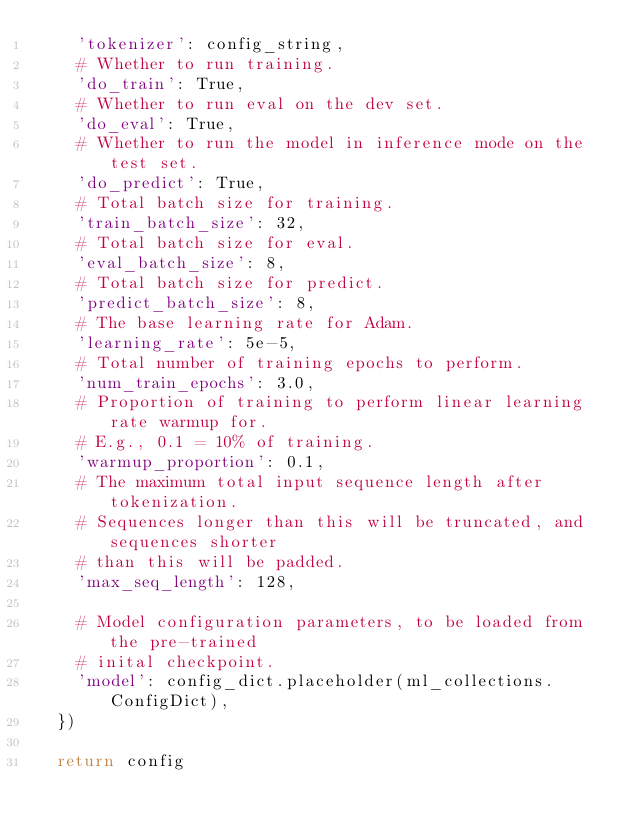Convert code to text. <code><loc_0><loc_0><loc_500><loc_500><_Python_>    'tokenizer': config_string,
    # Whether to run training.
    'do_train': True,
    # Whether to run eval on the dev set.
    'do_eval': True,
    # Whether to run the model in inference mode on the test set.
    'do_predict': True,
    # Total batch size for training.
    'train_batch_size': 32,
    # Total batch size for eval.
    'eval_batch_size': 8,
    # Total batch size for predict.
    'predict_batch_size': 8,
    # The base learning rate for Adam.
    'learning_rate': 5e-5,
    # Total number of training epochs to perform.
    'num_train_epochs': 3.0,
    # Proportion of training to perform linear learning rate warmup for.
    # E.g., 0.1 = 10% of training.
    'warmup_proportion': 0.1,
    # The maximum total input sequence length after tokenization.
    # Sequences longer than this will be truncated, and sequences shorter
    # than this will be padded. 
    'max_seq_length': 128,

    # Model configuration parameters, to be loaded from the pre-trained
    # inital checkpoint. 
    'model': config_dict.placeholder(ml_collections.ConfigDict),
  })    

  return config</code> 